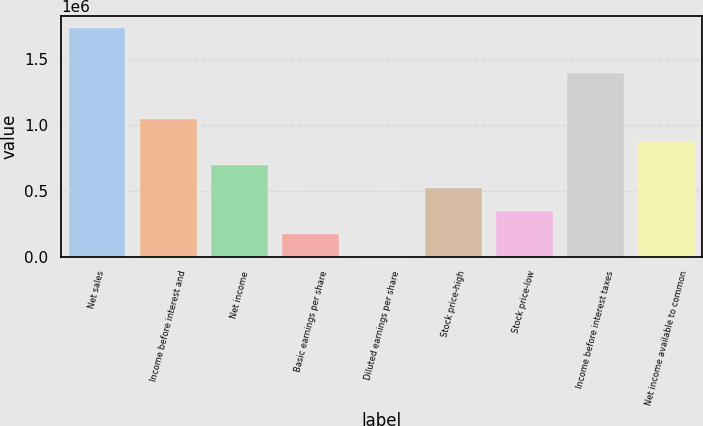<chart> <loc_0><loc_0><loc_500><loc_500><bar_chart><fcel>Net sales<fcel>Income before interest and<fcel>Net income<fcel>Basic earnings per share<fcel>Diluted earnings per share<fcel>Stock price-high<fcel>Stock price-low<fcel>Income before interest taxes<fcel>Net income available to common<nl><fcel>1.73586e+06<fcel>1.04151e+06<fcel>694343<fcel>173586<fcel>0.45<fcel>520758<fcel>347172<fcel>1.38869e+06<fcel>867929<nl></chart> 